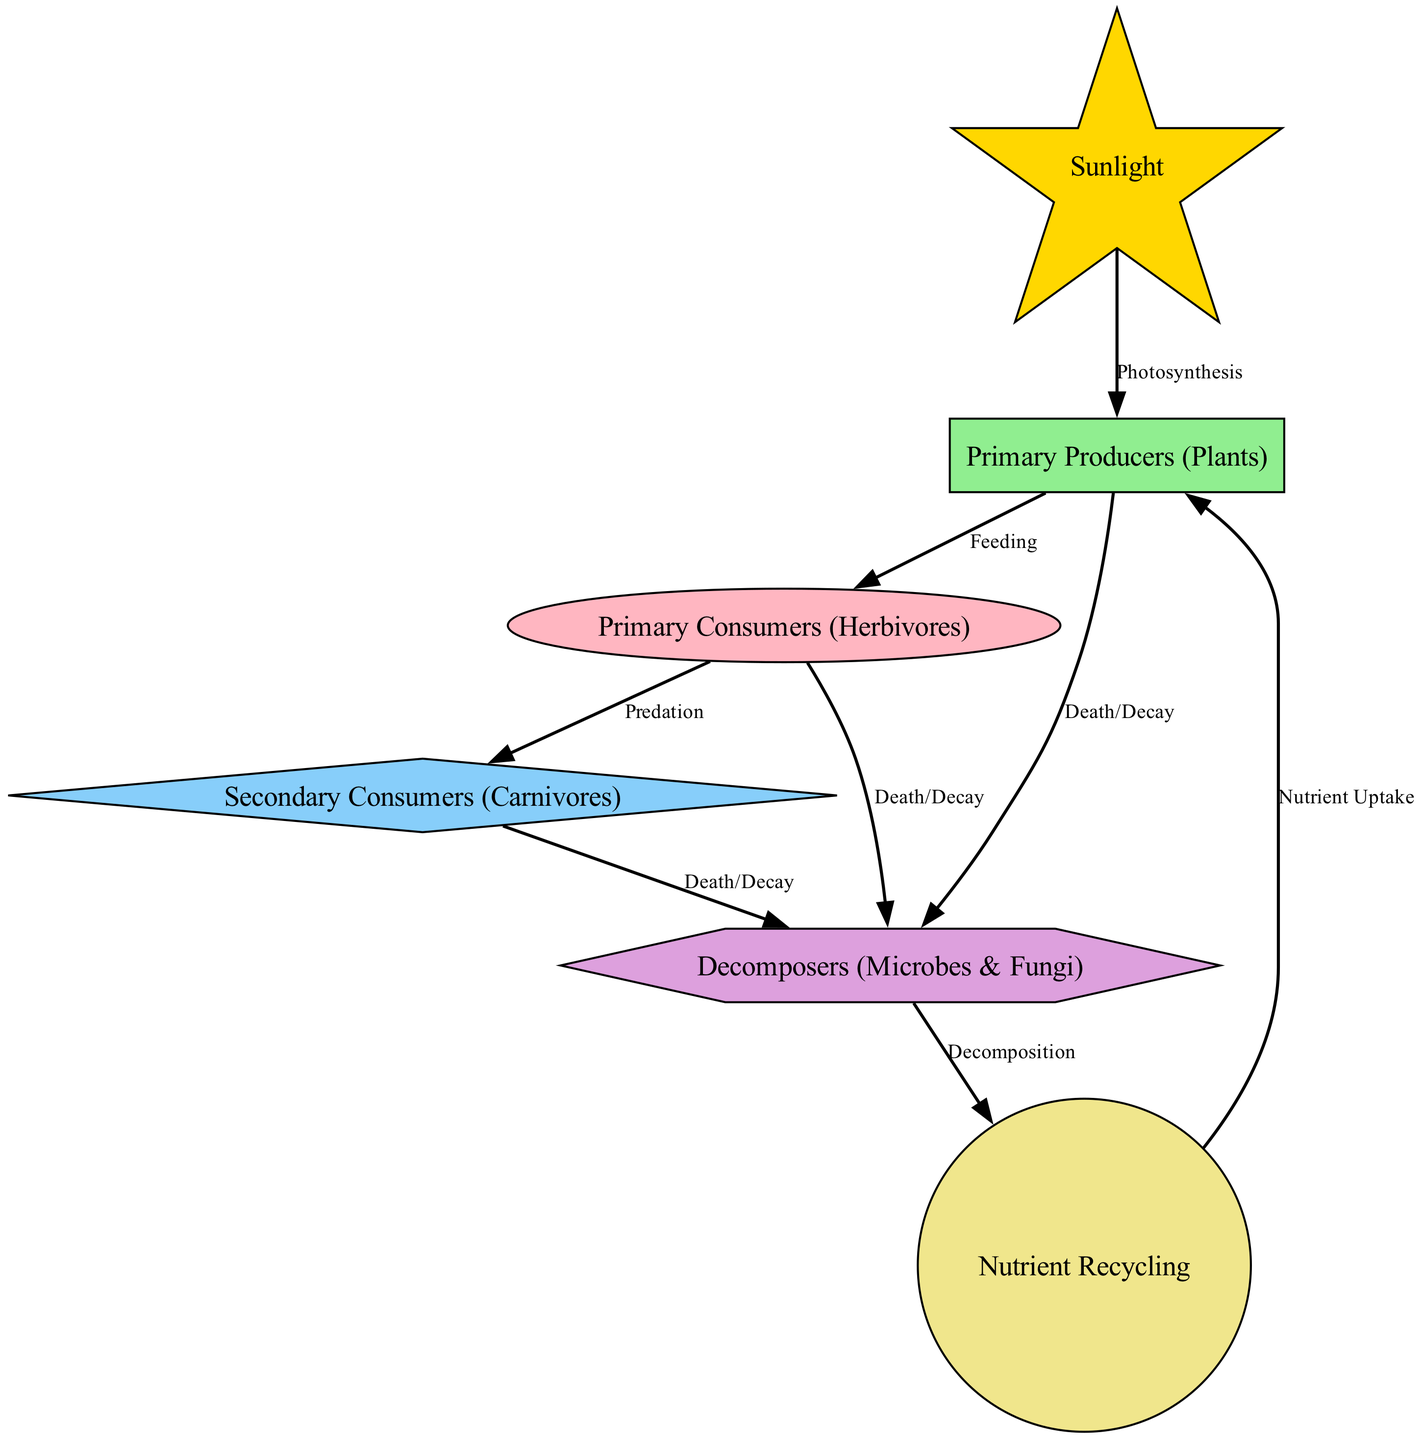What is the role of sunlight in the food chain? Sunlight is the primary source of energy captured by primary producers (plants) through photosynthesis. It is the starting point of energy flow within the food chain.
Answer: Photosynthesis How many main components are there in the diagram? The diagram consists of a total of six main components, which are interconnected in a food chain.
Answer: Six Which node directly feeds into primary consumers? The primary producers (plants) are the only node that feeds directly into primary consumers (herbivores) in the food chain as they provide them with the necessary nutrients.
Answer: Primary Producers What process connects decomposers to nutrient recycling? Decomposition is the process that links decomposers to nutrient recycling, as it involves breaking down organic matter and returning nutrients to the soil for reuse by plants.
Answer: Decomposition How many ways can primary consumers impact decomposers? Primary consumers can impact decomposers in two ways: they can die and decay, which enriches the soil, or they can also have their own organic waste contribute to the decomposition process.
Answer: Two Which two nodes are directly connected by the label "Predation"? The primary consumers (herbivores) and secondary consumers (carnivores) are connected by the label "Predation," indicating the feeding relationship between these two trophic levels.
Answer: Primary Consumers and Secondary Consumers What process is indicated between secondary consumers and decomposers? The process indicated between secondary consumers and decomposers is “Death/Decay,” referring to the natural cycle where dead organisms are broken down and returned to the ecosystem.
Answer: Death/Decay How does nutrient recycling begin its cycle again? Nutrient recycling begins again when primary producers uptake nutrients that have been recycled after decomposition, thus sustaining their growth and continuing the food chain.
Answer: Nutrient Uptake What is the role of decomposers in the food chain? Decomposers, consisting of microbes and fungi, play a crucial role in breaking down dead organic matter, returning nutrients to the soil, and enabling nutrient recycling in the ecosystem.
Answer: Breaking Down Dead Organic Matter 